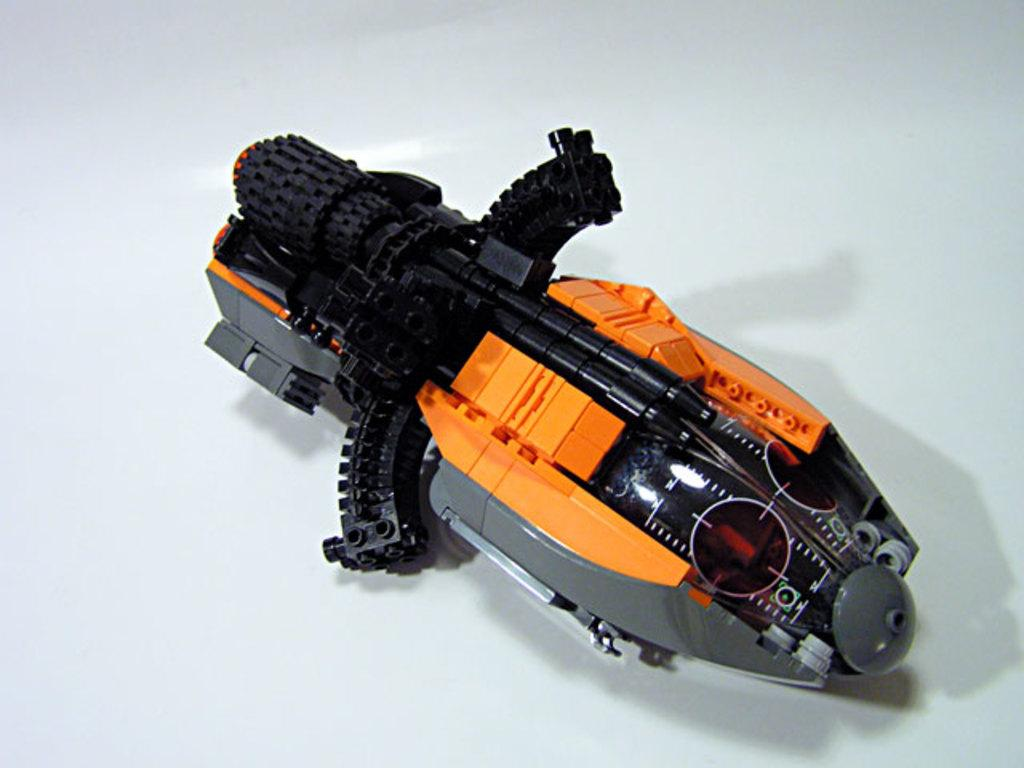What type of toy is present in the image? There is a black color toy gun in the image. How is the toy gun connected to another object? The toy gun is attached to an object. Where is the object with the toy gun placed? The object is placed on a surface. What color is the background of the image? The background of the image is white in color. What caption is written on the toy gun in the image? There is no caption written on the toy gun in the image. 